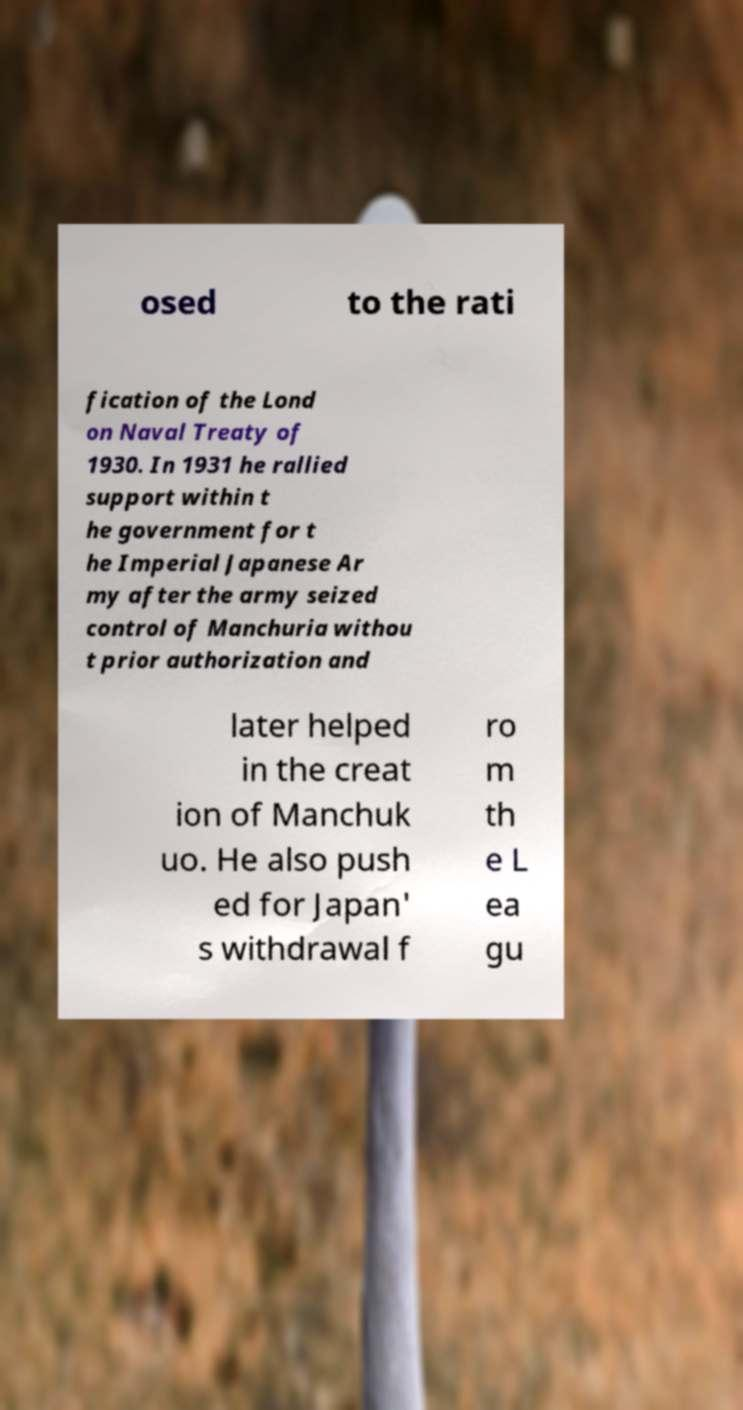Please read and relay the text visible in this image. What does it say? osed to the rati fication of the Lond on Naval Treaty of 1930. In 1931 he rallied support within t he government for t he Imperial Japanese Ar my after the army seized control of Manchuria withou t prior authorization and later helped in the creat ion of Manchuk uo. He also push ed for Japan' s withdrawal f ro m th e L ea gu 